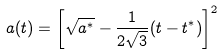Convert formula to latex. <formula><loc_0><loc_0><loc_500><loc_500>a ( t ) = \left [ \sqrt { a ^ { * } } - \frac { 1 } { 2 \sqrt { 3 } } ( t - t ^ { * } ) \right ] ^ { 2 }</formula> 